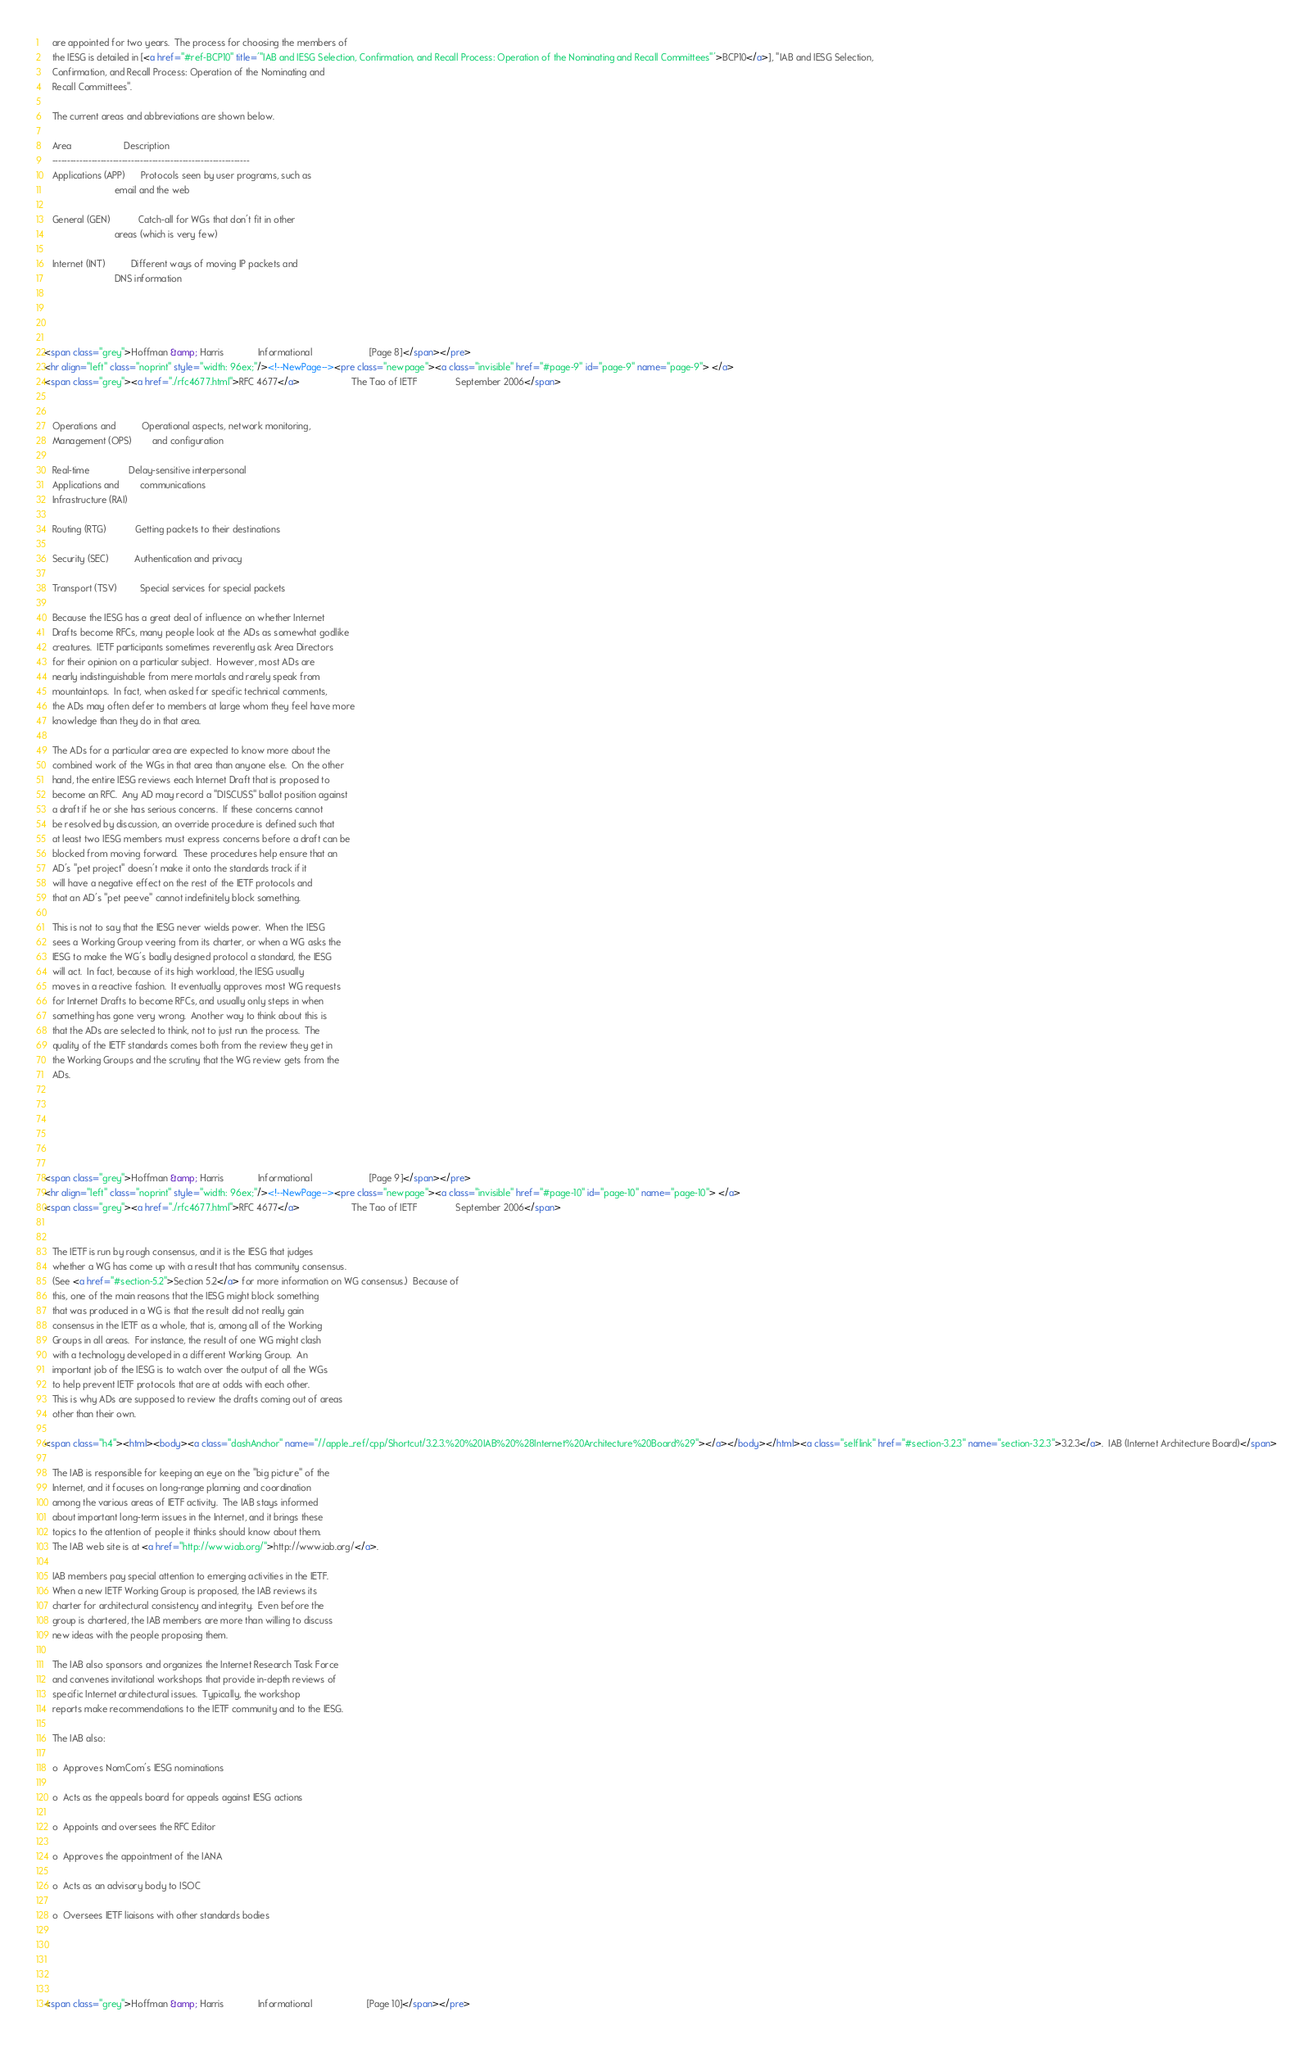Convert code to text. <code><loc_0><loc_0><loc_500><loc_500><_HTML_>   are appointed for two years.  The process for choosing the members of
   the IESG is detailed in [<a href="#ref-BCP10" title='"IAB and IESG Selection, Confirmation, and Recall Process: Operation of the Nominating and Recall Committees"'>BCP10</a>], "IAB and IESG Selection,
   Confirmation, and Recall Process: Operation of the Nominating and
   Recall Committees".

   The current areas and abbreviations are shown below.

   Area                    Description
   -----------------------------------------------------------------
   Applications (APP)      Protocols seen by user programs, such as
                           email and the web

   General (GEN)           Catch-all for WGs that don't fit in other
                           areas (which is very few)

   Internet (INT)          Different ways of moving IP packets and
                           DNS information




<span class="grey">Hoffman &amp; Harris             Informational                      [Page 8]</span></pre>
<hr align="left" class="noprint" style="width: 96ex;"/><!--NewPage--><pre class="newpage"><a class="invisible" href="#page-9" id="page-9" name="page-9"> </a>
<span class="grey"><a href="./rfc4677.html">RFC 4677</a>                    The Tao of IETF               September 2006</span>


   Operations and          Operational aspects, network monitoring,
   Management (OPS)        and configuration

   Real-time               Delay-sensitive interpersonal
   Applications and        communications
   Infrastructure (RAI)

   Routing (RTG)           Getting packets to their destinations

   Security (SEC)          Authentication and privacy

   Transport (TSV)         Special services for special packets

   Because the IESG has a great deal of influence on whether Internet
   Drafts become RFCs, many people look at the ADs as somewhat godlike
   creatures.  IETF participants sometimes reverently ask Area Directors
   for their opinion on a particular subject.  However, most ADs are
   nearly indistinguishable from mere mortals and rarely speak from
   mountaintops.  In fact, when asked for specific technical comments,
   the ADs may often defer to members at large whom they feel have more
   knowledge than they do in that area.

   The ADs for a particular area are expected to know more about the
   combined work of the WGs in that area than anyone else.  On the other
   hand, the entire IESG reviews each Internet Draft that is proposed to
   become an RFC.  Any AD may record a "DISCUSS" ballot position against
   a draft if he or she has serious concerns.  If these concerns cannot
   be resolved by discussion, an override procedure is defined such that
   at least two IESG members must express concerns before a draft can be
   blocked from moving forward.  These procedures help ensure that an
   AD's "pet project" doesn't make it onto the standards track if it
   will have a negative effect on the rest of the IETF protocols and
   that an AD's "pet peeve" cannot indefinitely block something.

   This is not to say that the IESG never wields power.  When the IESG
   sees a Working Group veering from its charter, or when a WG asks the
   IESG to make the WG's badly designed protocol a standard, the IESG
   will act.  In fact, because of its high workload, the IESG usually
   moves in a reactive fashion.  It eventually approves most WG requests
   for Internet Drafts to become RFCs, and usually only steps in when
   something has gone very wrong.  Another way to think about this is
   that the ADs are selected to think, not to just run the process.  The
   quality of the IETF standards comes both from the review they get in
   the Working Groups and the scrutiny that the WG review gets from the
   ADs.






<span class="grey">Hoffman &amp; Harris             Informational                      [Page 9]</span></pre>
<hr align="left" class="noprint" style="width: 96ex;"/><!--NewPage--><pre class="newpage"><a class="invisible" href="#page-10" id="page-10" name="page-10"> </a>
<span class="grey"><a href="./rfc4677.html">RFC 4677</a>                    The Tao of IETF               September 2006</span>


   The IETF is run by rough consensus, and it is the IESG that judges
   whether a WG has come up with a result that has community consensus.
   (See <a href="#section-5.2">Section 5.2</a> for more information on WG consensus.)  Because of
   this, one of the main reasons that the IESG might block something
   that was produced in a WG is that the result did not really gain
   consensus in the IETF as a whole, that is, among all of the Working
   Groups in all areas.  For instance, the result of one WG might clash
   with a technology developed in a different Working Group.  An
   important job of the IESG is to watch over the output of all the WGs
   to help prevent IETF protocols that are at odds with each other.
   This is why ADs are supposed to review the drafts coming out of areas
   other than their own.

<span class="h4"><html><body><a class="dashAnchor" name="//apple_ref/cpp/Shortcut/3.2.3.%20%20IAB%20%28Internet%20Architecture%20Board%29"></a></body></html><a class="selflink" href="#section-3.2.3" name="section-3.2.3">3.2.3</a>.  IAB (Internet Architecture Board)</span>

   The IAB is responsible for keeping an eye on the "big picture" of the
   Internet, and it focuses on long-range planning and coordination
   among the various areas of IETF activity.  The IAB stays informed
   about important long-term issues in the Internet, and it brings these
   topics to the attention of people it thinks should know about them.
   The IAB web site is at <a href="http://www.iab.org/">http://www.iab.org/</a>.

   IAB members pay special attention to emerging activities in the IETF.
   When a new IETF Working Group is proposed, the IAB reviews its
   charter for architectural consistency and integrity.  Even before the
   group is chartered, the IAB members are more than willing to discuss
   new ideas with the people proposing them.

   The IAB also sponsors and organizes the Internet Research Task Force
   and convenes invitational workshops that provide in-depth reviews of
   specific Internet architectural issues.  Typically, the workshop
   reports make recommendations to the IETF community and to the IESG.

   The IAB also:

   o  Approves NomCom's IESG nominations

   o  Acts as the appeals board for appeals against IESG actions

   o  Appoints and oversees the RFC Editor

   o  Approves the appointment of the IANA

   o  Acts as an advisory body to ISOC

   o  Oversees IETF liaisons with other standards bodies





<span class="grey">Hoffman &amp; Harris             Informational                     [Page 10]</span></pre></code> 